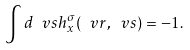<formula> <loc_0><loc_0><loc_500><loc_500>\int d \ v s h ^ { \sigma } _ { x } ( \ v r , \ v s ) = - 1 .</formula> 